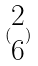<formula> <loc_0><loc_0><loc_500><loc_500>( \begin{matrix} 2 \\ 6 \end{matrix} )</formula> 